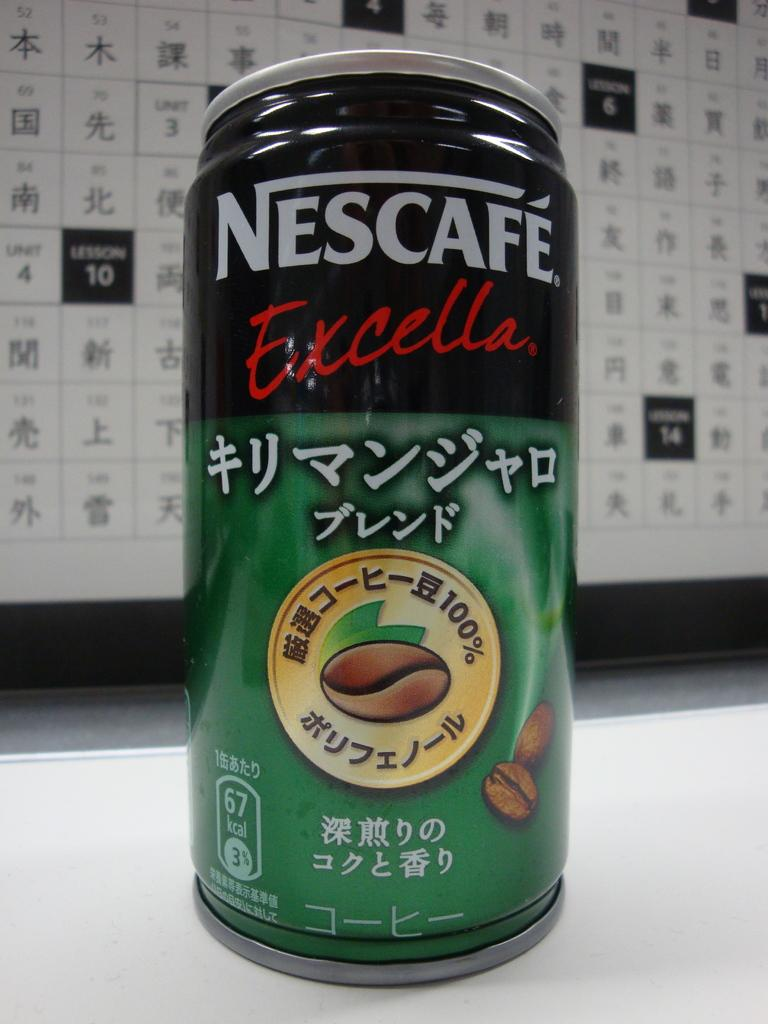What object is on the surface in the image? There is a tin on the surface in the image. What can be seen in the background of the image? There is a poster in the background of the image. What type of watch is being worn by the person driving to dinner in the image? There is no person, driving, or dinner depicted in the image; it only features a tin on a surface and a poster in the background. 